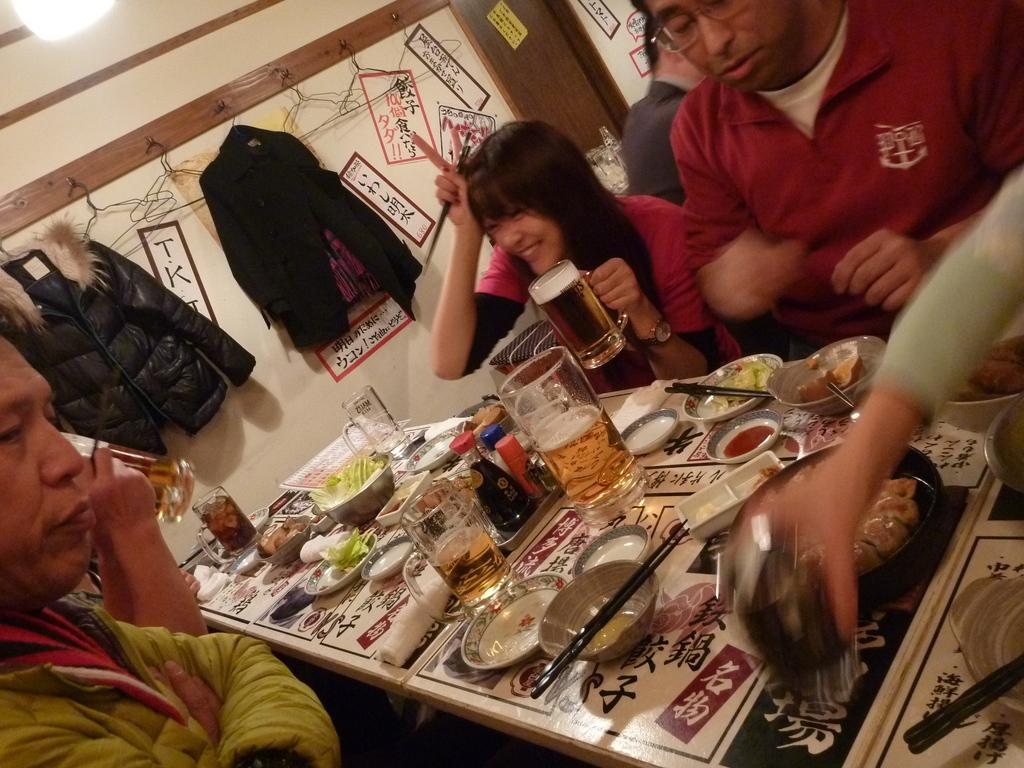What are the people in the image doing? The people in the image are sitting in front of the table. What can be seen on the table? There are many things placed on the table. Where are the coats located in the image? The coats are hanged on the wall. How many worms can be seen crawling on the table in the image? There are no worms present in the image; the table has many things placed on it, but none of them are worms. 